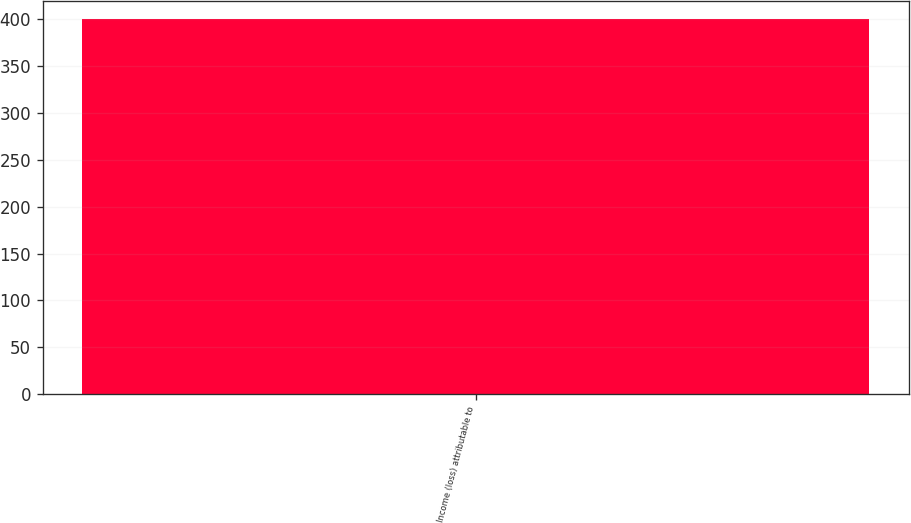Convert chart. <chart><loc_0><loc_0><loc_500><loc_500><bar_chart><fcel>Income (loss) attributable to<nl><fcel>400<nl></chart> 